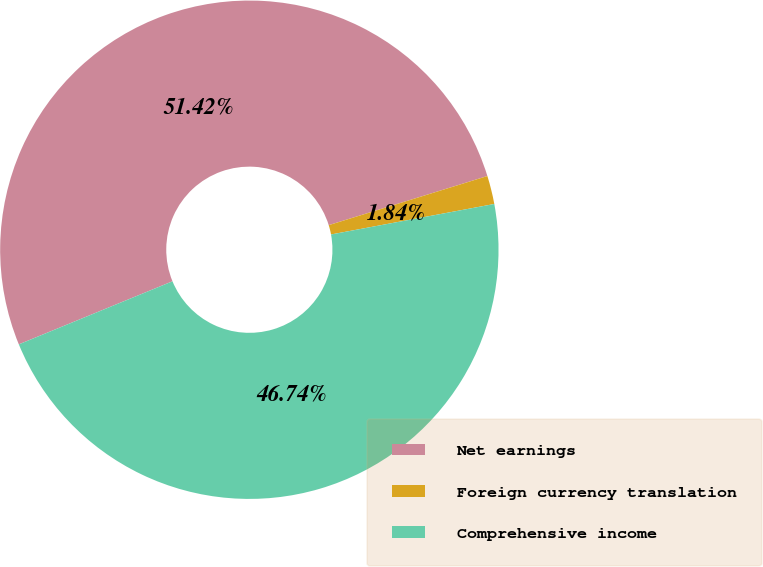Convert chart to OTSL. <chart><loc_0><loc_0><loc_500><loc_500><pie_chart><fcel>Net earnings<fcel>Foreign currency translation<fcel>Comprehensive income<nl><fcel>51.42%<fcel>1.84%<fcel>46.74%<nl></chart> 